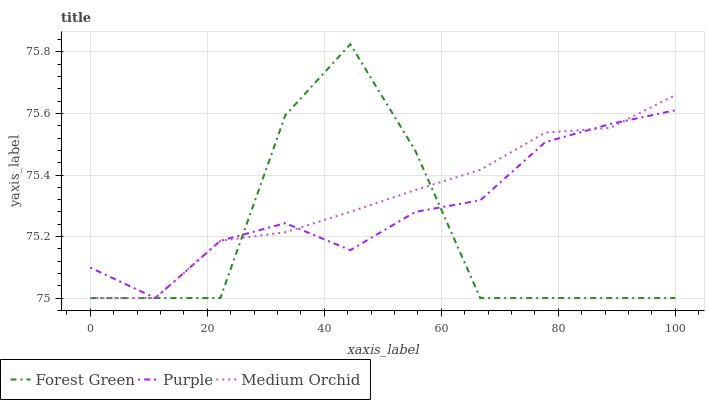Does Forest Green have the minimum area under the curve?
Answer yes or no. Yes. Does Medium Orchid have the maximum area under the curve?
Answer yes or no. Yes. Does Medium Orchid have the minimum area under the curve?
Answer yes or no. No. Does Forest Green have the maximum area under the curve?
Answer yes or no. No. Is Medium Orchid the smoothest?
Answer yes or no. Yes. Is Forest Green the roughest?
Answer yes or no. Yes. Is Forest Green the smoothest?
Answer yes or no. No. Is Medium Orchid the roughest?
Answer yes or no. No. Does Purple have the lowest value?
Answer yes or no. Yes. Does Forest Green have the highest value?
Answer yes or no. Yes. Does Medium Orchid have the highest value?
Answer yes or no. No. Does Purple intersect Forest Green?
Answer yes or no. Yes. Is Purple less than Forest Green?
Answer yes or no. No. Is Purple greater than Forest Green?
Answer yes or no. No. 